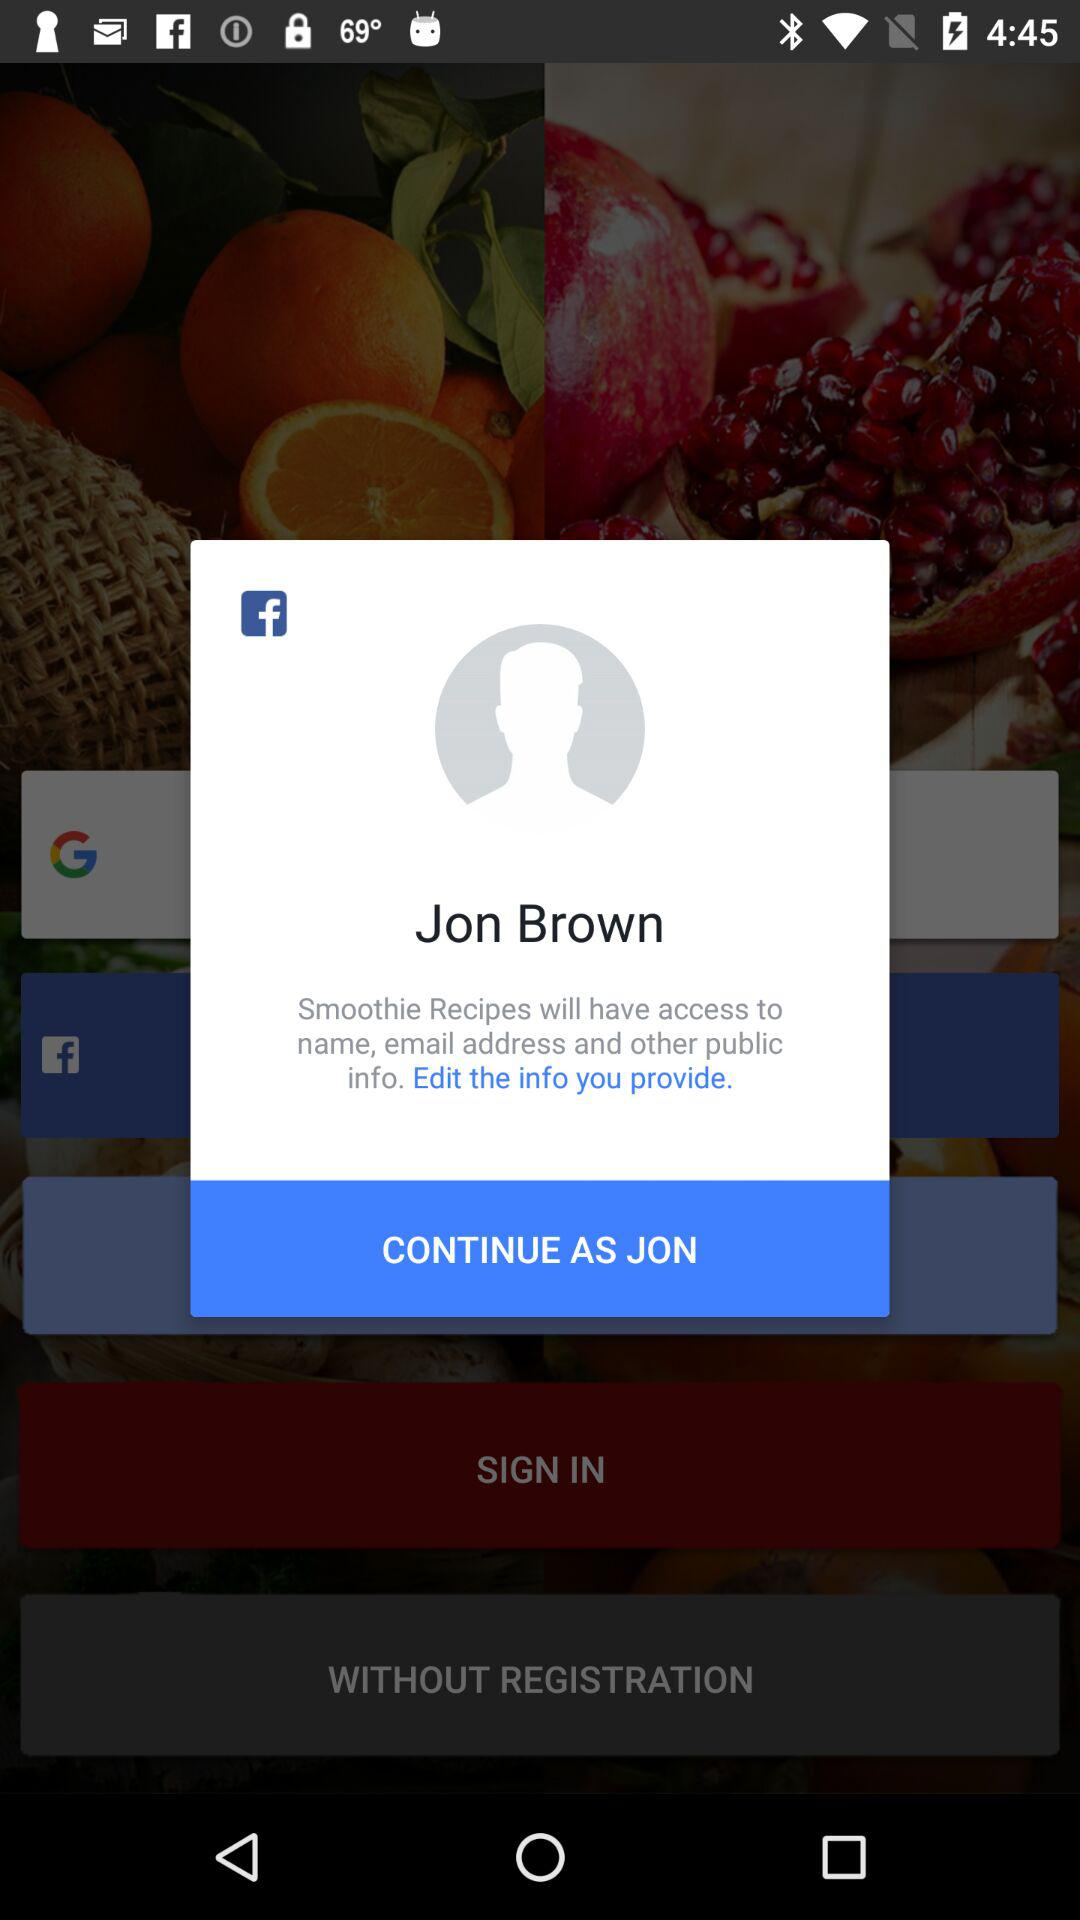What is the user's name? The user's name is "Jon Brown". 